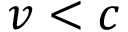<formula> <loc_0><loc_0><loc_500><loc_500>v < c</formula> 